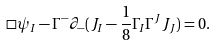Convert formula to latex. <formula><loc_0><loc_0><loc_500><loc_500>\Box \psi _ { I } - \Gamma ^ { - } \partial _ { - } ( J _ { I } - \frac { 1 } { 8 } \Gamma _ { I } \Gamma ^ { J } J _ { J } ) = 0 .</formula> 